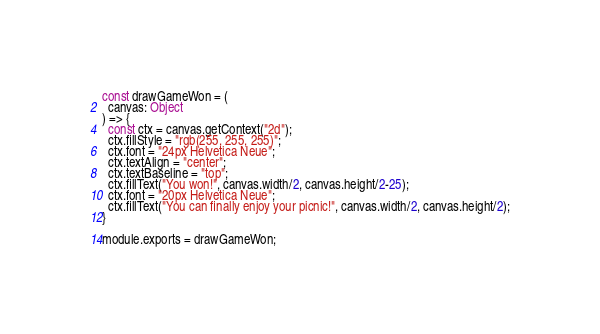<code> <loc_0><loc_0><loc_500><loc_500><_JavaScript_>
const drawGameWon = (
  canvas: Object
) => {
  const ctx = canvas.getContext("2d");
  ctx.fillStyle = "rgb(255, 255, 255)";
  ctx.font = "24px Helvetica Neue";
  ctx.textAlign = "center";
  ctx.textBaseline = "top";
  ctx.fillText("You won!", canvas.width/2, canvas.height/2-25);
  ctx.font = "20px Helvetica Neue";
  ctx.fillText("You can finally enjoy your picnic!", canvas.width/2, canvas.height/2);
}

module.exports = drawGameWon;
</code> 